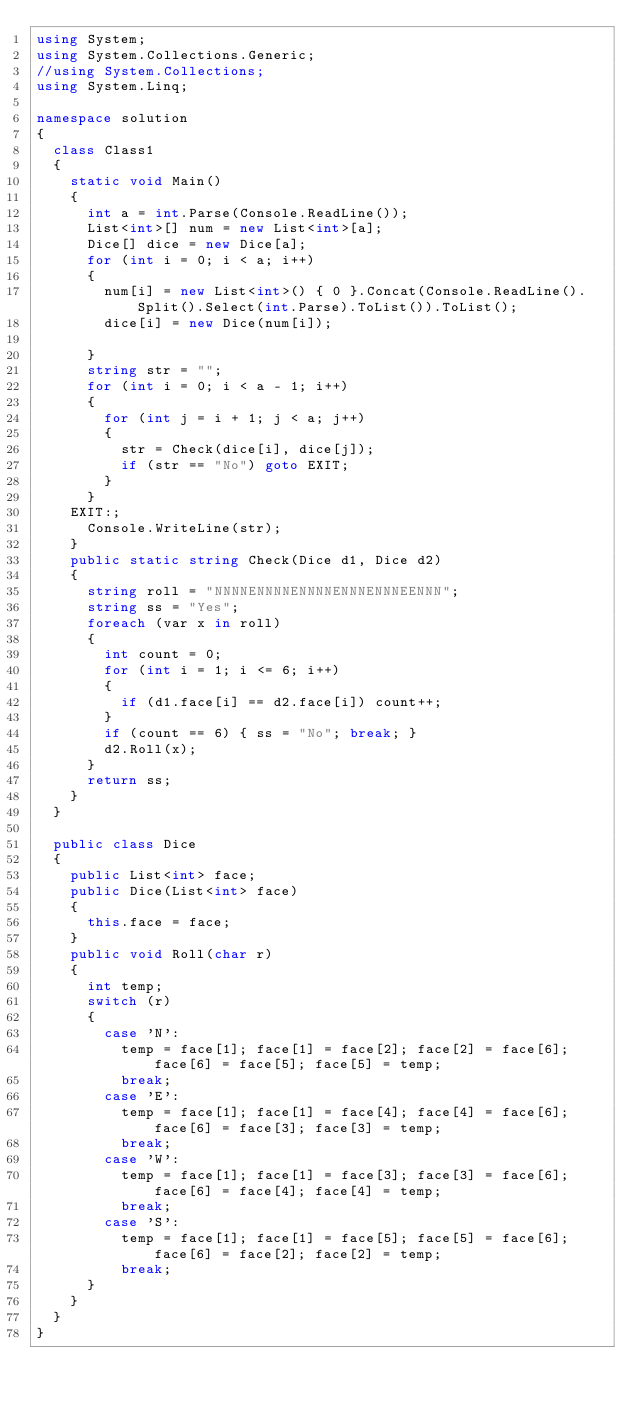Convert code to text. <code><loc_0><loc_0><loc_500><loc_500><_C#_>using System;
using System.Collections.Generic;
//using System.Collections;
using System.Linq;

namespace solution
{
  class Class1
  {
    static void Main()
    {
      int a = int.Parse(Console.ReadLine());
      List<int>[] num = new List<int>[a];
      Dice[] dice = new Dice[a];
      for (int i = 0; i < a; i++)
      {
        num[i] = new List<int>() { 0 }.Concat(Console.ReadLine().Split().Select(int.Parse).ToList()).ToList();
        dice[i] = new Dice(num[i]);

      }
      string str = "";
      for (int i = 0; i < a - 1; i++)
      {
        for (int j = i + 1; j < a; j++)
        {
          str = Check(dice[i], dice[j]);
          if (str == "No") goto EXIT;
        }
      }
    EXIT:;
      Console.WriteLine(str);
    }
    public static string Check(Dice d1, Dice d2)
    {
      string roll = "NNNNENNNNENNNNENNNENNNEENNN";
      string ss = "Yes";
      foreach (var x in roll)
      {
        int count = 0;
        for (int i = 1; i <= 6; i++)
        {
          if (d1.face[i] == d2.face[i]) count++;
        }
        if (count == 6) { ss = "No"; break; }
        d2.Roll(x);
      }
      return ss;
    }
  }

  public class Dice
  {
    public List<int> face;
    public Dice(List<int> face)
    {
      this.face = face;
    }
    public void Roll(char r)
    {
      int temp;
      switch (r)
      {
        case 'N':
          temp = face[1]; face[1] = face[2]; face[2] = face[6]; face[6] = face[5]; face[5] = temp;
          break;
        case 'E':
          temp = face[1]; face[1] = face[4]; face[4] = face[6]; face[6] = face[3]; face[3] = temp;
          break;
        case 'W':
          temp = face[1]; face[1] = face[3]; face[3] = face[6]; face[6] = face[4]; face[4] = temp;
          break;
        case 'S':
          temp = face[1]; face[1] = face[5]; face[5] = face[6]; face[6] = face[2]; face[2] = temp;
          break;
      }
    }
  }
}






</code> 